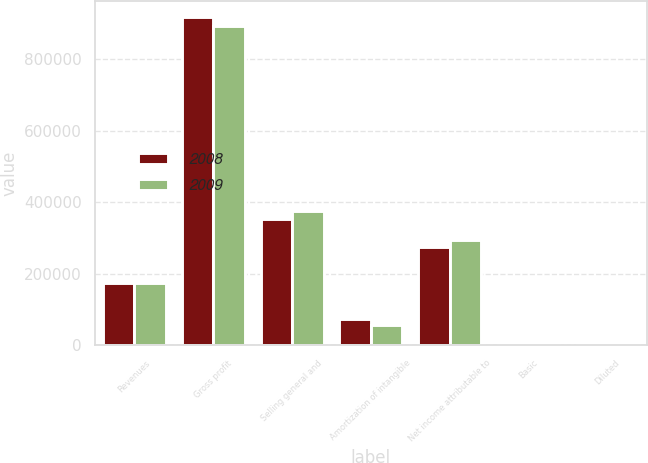Convert chart to OTSL. <chart><loc_0><loc_0><loc_500><loc_500><stacked_bar_chart><ecel><fcel>Revenues<fcel>Gross profit<fcel>Selling general and<fcel>Amortization of intangible<fcel>Net income attributable to<fcel>Basic<fcel>Diluted<nl><fcel>2008<fcel>174254<fcel>917166<fcel>352683<fcel>74270<fcel>274238<fcel>1.46<fcel>1.37<nl><fcel>2009<fcel>174254<fcel>893264<fcel>374897<fcel>56596<fcel>294351<fcel>1.41<fcel>1.39<nl></chart> 